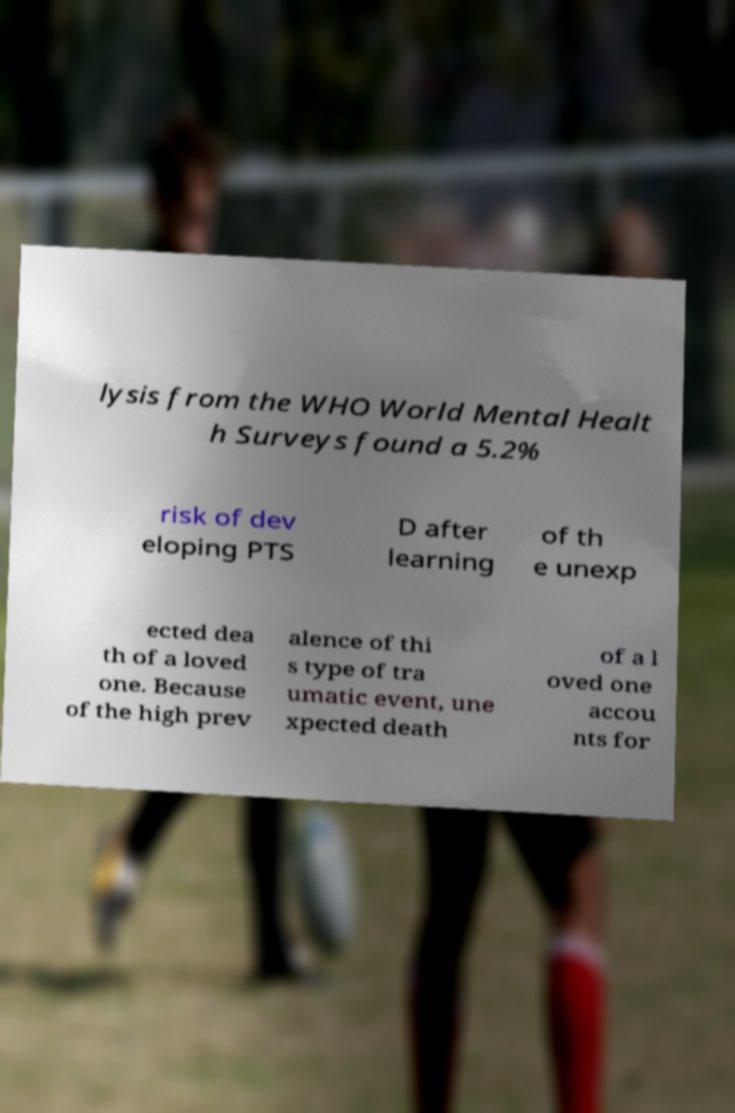I need the written content from this picture converted into text. Can you do that? lysis from the WHO World Mental Healt h Surveys found a 5.2% risk of dev eloping PTS D after learning of th e unexp ected dea th of a loved one. Because of the high prev alence of thi s type of tra umatic event, une xpected death of a l oved one accou nts for 